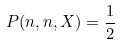<formula> <loc_0><loc_0><loc_500><loc_500>P ( n , n , X ) = \frac { 1 } { 2 }</formula> 